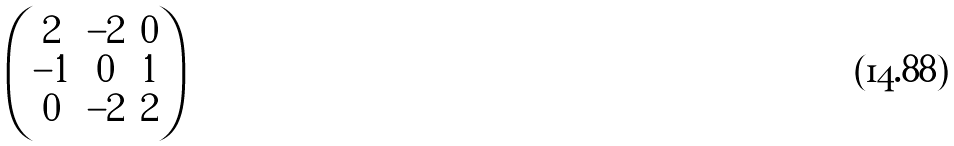Convert formula to latex. <formula><loc_0><loc_0><loc_500><loc_500>\begin{pmatrix} 2 & - 2 & 0 \\ - 1 & 0 & 1 \\ 0 & - 2 & 2 \end{pmatrix}</formula> 